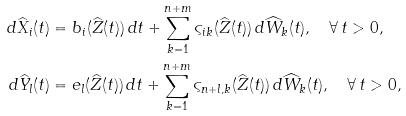Convert formula to latex. <formula><loc_0><loc_0><loc_500><loc_500>d \widehat { X } _ { i } ( t ) & = b _ { i } ( \widehat { Z } ( t ) ) \, d t + \sum _ { k = 1 } ^ { n + m } \varsigma _ { i k } ( \widehat { Z } ( t ) ) \, d \widehat { W } _ { k } ( t ) , \quad \forall \, t > 0 , \\ d \widehat { Y } _ { l } ( t ) & = e _ { l } ( \widehat { Z } ( t ) ) \, d t + \sum _ { k = 1 } ^ { n + m } \varsigma _ { n + l , k } ( \widehat { Z } ( t ) ) \, d \widehat { W } _ { k } ( t ) , \quad \forall \, t > 0 ,</formula> 